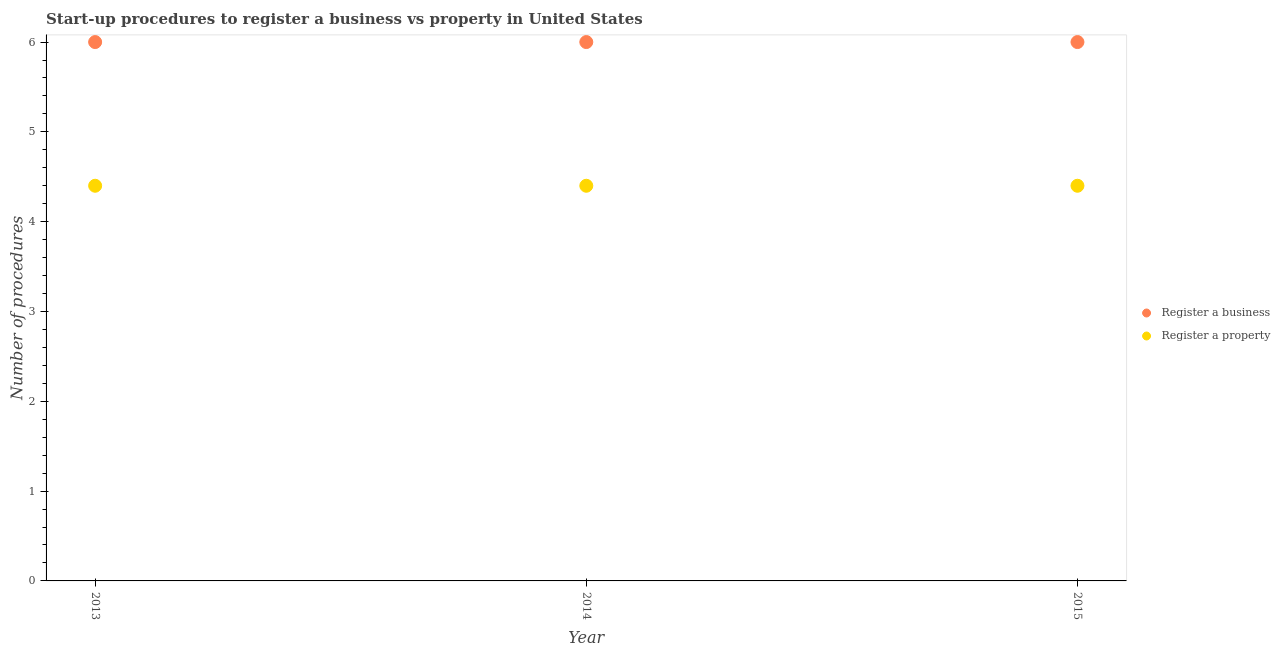Is the number of dotlines equal to the number of legend labels?
Offer a very short reply. Yes. What is the number of procedures to register a property in 2014?
Your answer should be compact. 4.4. Across all years, what is the maximum number of procedures to register a property?
Provide a short and direct response. 4.4. In which year was the number of procedures to register a property maximum?
Provide a succinct answer. 2013. In which year was the number of procedures to register a property minimum?
Provide a short and direct response. 2013. What is the total number of procedures to register a business in the graph?
Your answer should be compact. 18. What is the difference between the number of procedures to register a property in 2013 and the number of procedures to register a business in 2015?
Keep it short and to the point. -1.6. In the year 2014, what is the difference between the number of procedures to register a business and number of procedures to register a property?
Keep it short and to the point. 1.6. In how many years, is the number of procedures to register a business greater than 4.8?
Your answer should be very brief. 3. What is the ratio of the number of procedures to register a business in 2013 to that in 2015?
Your response must be concise. 1. Is the difference between the number of procedures to register a business in 2013 and 2014 greater than the difference between the number of procedures to register a property in 2013 and 2014?
Provide a short and direct response. No. What is the difference between the highest and the second highest number of procedures to register a property?
Your answer should be compact. 0. Does the number of procedures to register a property monotonically increase over the years?
Your response must be concise. No. Is the number of procedures to register a business strictly greater than the number of procedures to register a property over the years?
Provide a short and direct response. Yes. Is the number of procedures to register a business strictly less than the number of procedures to register a property over the years?
Your answer should be compact. No. What is the difference between two consecutive major ticks on the Y-axis?
Make the answer very short. 1. Are the values on the major ticks of Y-axis written in scientific E-notation?
Offer a terse response. No. Does the graph contain any zero values?
Offer a very short reply. No. How many legend labels are there?
Provide a short and direct response. 2. What is the title of the graph?
Ensure brevity in your answer.  Start-up procedures to register a business vs property in United States. What is the label or title of the Y-axis?
Provide a succinct answer. Number of procedures. What is the Number of procedures in Register a business in 2015?
Provide a succinct answer. 6. Across all years, what is the maximum Number of procedures in Register a business?
Offer a very short reply. 6. Across all years, what is the minimum Number of procedures of Register a property?
Provide a short and direct response. 4.4. What is the total Number of procedures in Register a business in the graph?
Make the answer very short. 18. What is the difference between the Number of procedures of Register a business in 2013 and that in 2014?
Give a very brief answer. 0. What is the difference between the Number of procedures of Register a business in 2013 and that in 2015?
Your answer should be compact. 0. What is the difference between the Number of procedures in Register a property in 2013 and that in 2015?
Your answer should be compact. 0. What is the difference between the Number of procedures in Register a business in 2014 and that in 2015?
Keep it short and to the point. 0. What is the difference between the Number of procedures in Register a business in 2014 and the Number of procedures in Register a property in 2015?
Offer a very short reply. 1.6. In the year 2014, what is the difference between the Number of procedures of Register a business and Number of procedures of Register a property?
Keep it short and to the point. 1.6. In the year 2015, what is the difference between the Number of procedures of Register a business and Number of procedures of Register a property?
Keep it short and to the point. 1.6. What is the ratio of the Number of procedures of Register a business in 2013 to that in 2015?
Provide a succinct answer. 1. What is the ratio of the Number of procedures in Register a property in 2013 to that in 2015?
Make the answer very short. 1. What is the ratio of the Number of procedures in Register a business in 2014 to that in 2015?
Make the answer very short. 1. What is the difference between the highest and the second highest Number of procedures in Register a business?
Give a very brief answer. 0. What is the difference between the highest and the lowest Number of procedures of Register a business?
Ensure brevity in your answer.  0. 